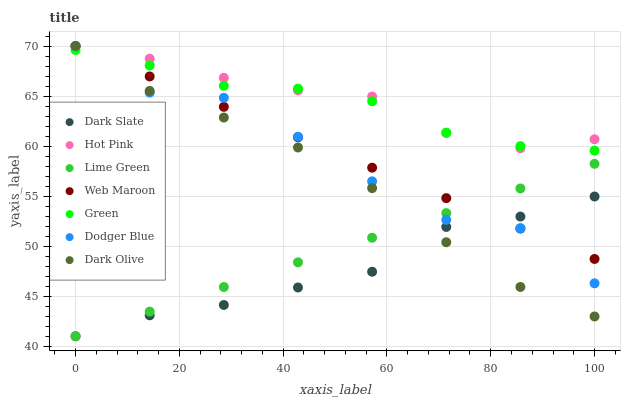Does Dark Slate have the minimum area under the curve?
Answer yes or no. Yes. Does Hot Pink have the maximum area under the curve?
Answer yes or no. Yes. Does Web Maroon have the minimum area under the curve?
Answer yes or no. No. Does Web Maroon have the maximum area under the curve?
Answer yes or no. No. Is Web Maroon the smoothest?
Answer yes or no. Yes. Is Dodger Blue the roughest?
Answer yes or no. Yes. Is Hot Pink the smoothest?
Answer yes or no. No. Is Hot Pink the roughest?
Answer yes or no. No. Does Dark Slate have the lowest value?
Answer yes or no. Yes. Does Web Maroon have the lowest value?
Answer yes or no. No. Does Dodger Blue have the highest value?
Answer yes or no. Yes. Does Dark Slate have the highest value?
Answer yes or no. No. Is Dark Slate less than Hot Pink?
Answer yes or no. Yes. Is Hot Pink greater than Dark Slate?
Answer yes or no. Yes. Does Dodger Blue intersect Green?
Answer yes or no. Yes. Is Dodger Blue less than Green?
Answer yes or no. No. Is Dodger Blue greater than Green?
Answer yes or no. No. Does Dark Slate intersect Hot Pink?
Answer yes or no. No. 